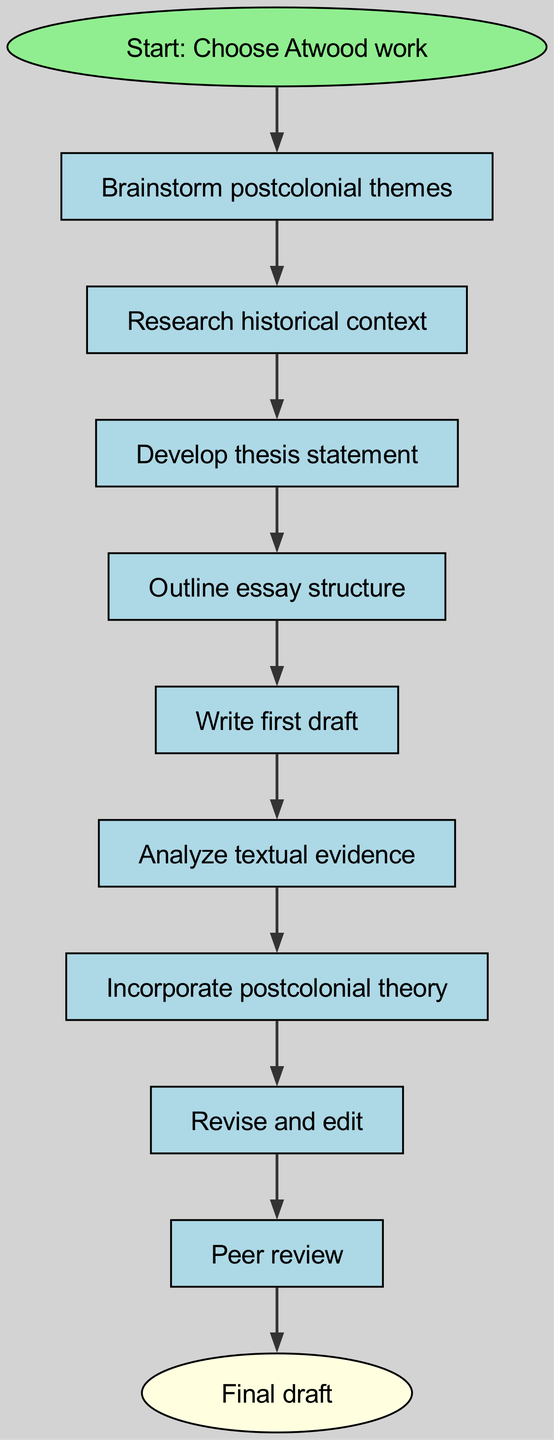What is the first step in the writing process? The diagram starts with the node labeled "Start: Choose Atwood work", indicating this is the first action to be taken.
Answer: Start: Choose Atwood work How many nodes are in the diagram? By counting the nodes listed in the data provided, there are a total of 11 distinct nodes in the flowchart.
Answer: 11 Which node comes directly after "Outline essay structure"? The flowchart indicates that after outlining the essay structure, the next step is "Write first draft".
Answer: Write first draft What is the last step before the final draft? Referring to the diagram, the last action to be taken before reaching the final draft is "Peer review".
Answer: Peer review What connects "Analyze textual evidence" and "Incorporate postcolonial theory"? The flowchart indicates a direct connection (an edge) from "Analyze textual evidence" to "Incorporate postcolonial theory", showing that the latter follows the former in the writing process.
Answer: Incorporate postcolonial theory Why is "Revise and edit" significant in the process? "Revise and edit" is crucial because it occurs before "Peer review", making it a key preparation step to improve the essay quality before receiving feedback.
Answer: Preparation step How many total edges connect the nodes in the flowchart? Each node's connections can be counted, and there are ten edges in total connecting the sequence of actions throughout the diagram.
Answer: 10 What type of node is "Final draft"? The diagram categorizes "Final draft" as an ellipse, indicating it is an endpoint in the writing process.
Answer: Ellipse Which step includes incorporating theoretical frameworks? The step where theoretical frameworks are included is "Incorporate postcolonial theory", as it directly highlights the importance of postcolonial literature theories in the essay.
Answer: Incorporate postcolonial theory 